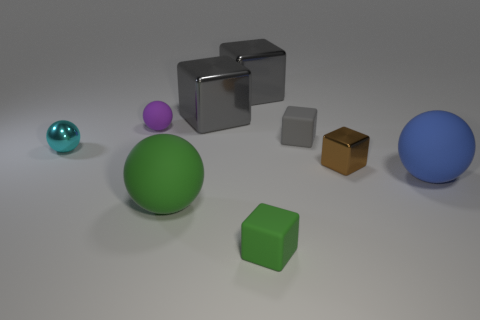Subtract all large green balls. How many balls are left? 3 Subtract all blue cylinders. How many gray blocks are left? 3 Add 1 large blocks. How many objects exist? 10 Subtract 2 balls. How many balls are left? 2 Subtract all purple spheres. How many spheres are left? 3 Subtract all cubes. How many objects are left? 4 Add 7 tiny purple things. How many tiny purple things exist? 8 Subtract 0 gray spheres. How many objects are left? 9 Subtract all green balls. Subtract all brown cylinders. How many balls are left? 3 Subtract all yellow matte cylinders. Subtract all big green rubber balls. How many objects are left? 8 